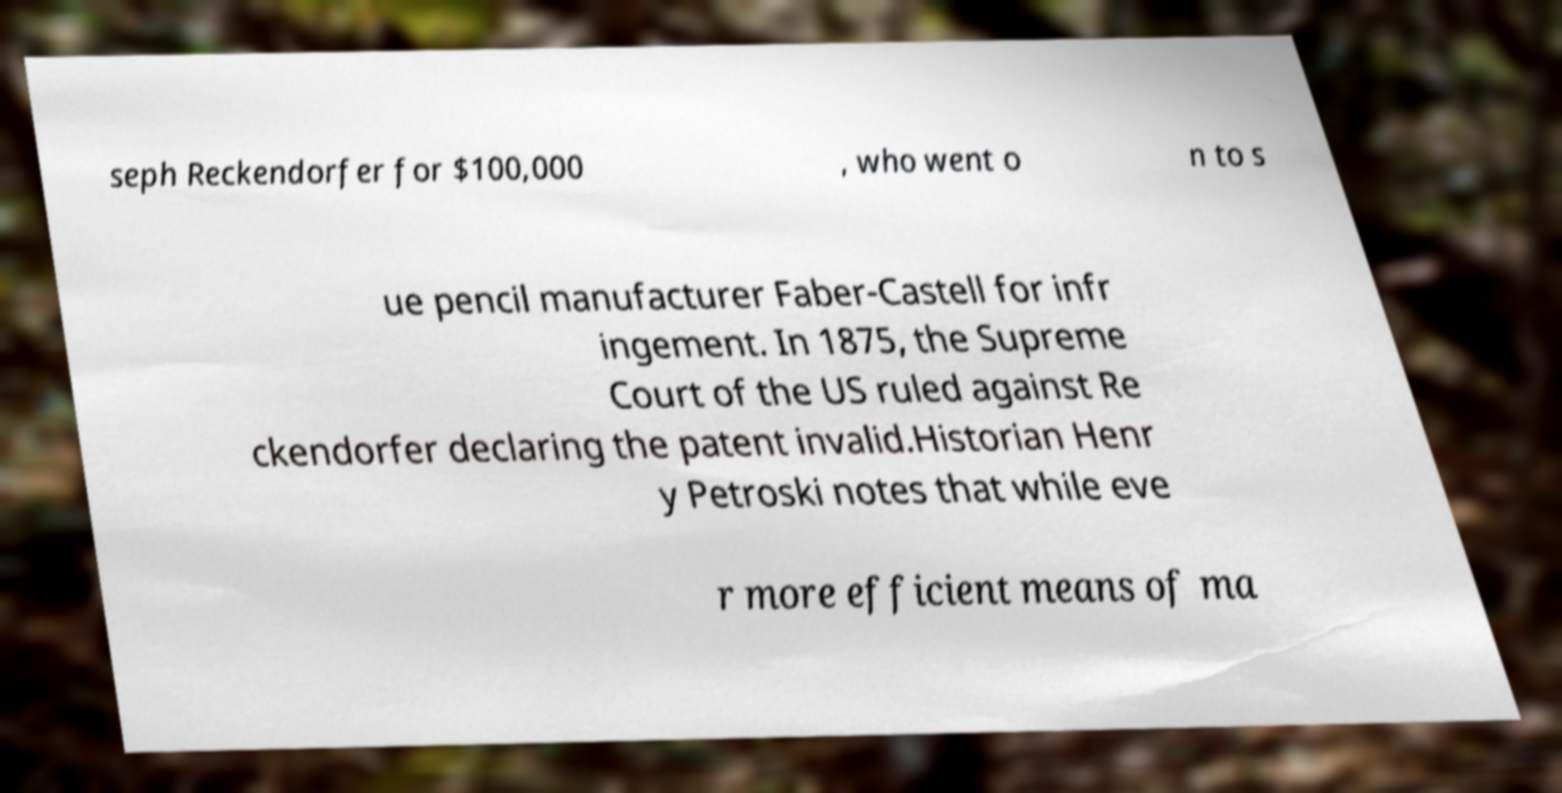What messages or text are displayed in this image? I need them in a readable, typed format. seph Reckendorfer for $100,000 , who went o n to s ue pencil manufacturer Faber-Castell for infr ingement. In 1875, the Supreme Court of the US ruled against Re ckendorfer declaring the patent invalid.Historian Henr y Petroski notes that while eve r more efficient means of ma 